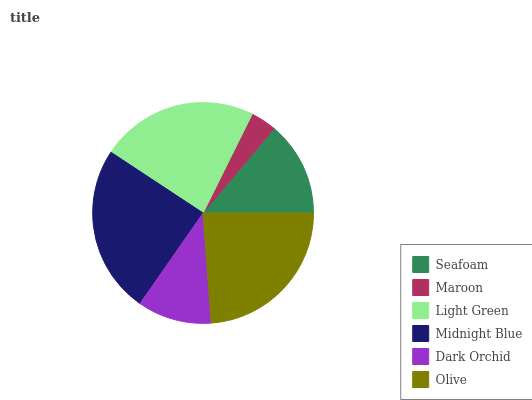Is Maroon the minimum?
Answer yes or no. Yes. Is Midnight Blue the maximum?
Answer yes or no. Yes. Is Light Green the minimum?
Answer yes or no. No. Is Light Green the maximum?
Answer yes or no. No. Is Light Green greater than Maroon?
Answer yes or no. Yes. Is Maroon less than Light Green?
Answer yes or no. Yes. Is Maroon greater than Light Green?
Answer yes or no. No. Is Light Green less than Maroon?
Answer yes or no. No. Is Light Green the high median?
Answer yes or no. Yes. Is Seafoam the low median?
Answer yes or no. Yes. Is Midnight Blue the high median?
Answer yes or no. No. Is Midnight Blue the low median?
Answer yes or no. No. 